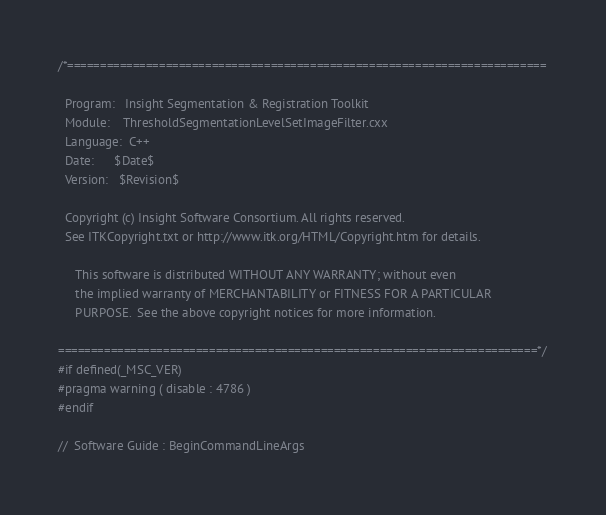Convert code to text. <code><loc_0><loc_0><loc_500><loc_500><_C++_>/*=========================================================================

  Program:   Insight Segmentation & Registration Toolkit
  Module:    ThresholdSegmentationLevelSetImageFilter.cxx
  Language:  C++
  Date:      $Date$
  Version:   $Revision$

  Copyright (c) Insight Software Consortium. All rights reserved.
  See ITKCopyright.txt or http://www.itk.org/HTML/Copyright.htm for details.

     This software is distributed WITHOUT ANY WARRANTY; without even 
     the implied warranty of MERCHANTABILITY or FITNESS FOR A PARTICULAR 
     PURPOSE.  See the above copyright notices for more information.

=========================================================================*/
#if defined(_MSC_VER)
#pragma warning ( disable : 4786 )
#endif

//  Software Guide : BeginCommandLineArgs</code> 